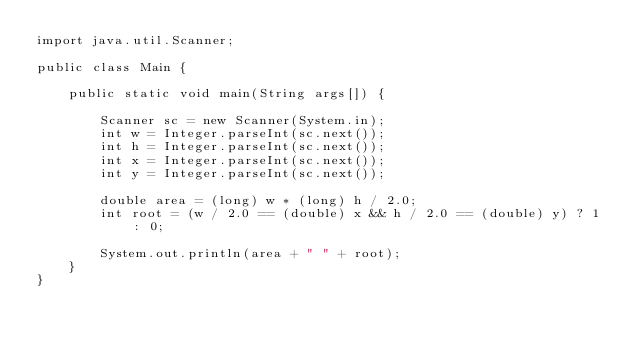Convert code to text. <code><loc_0><loc_0><loc_500><loc_500><_Java_>import java.util.Scanner;

public class Main {

    public static void main(String args[]) {

        Scanner sc = new Scanner(System.in);
        int w = Integer.parseInt(sc.next());
        int h = Integer.parseInt(sc.next());
        int x = Integer.parseInt(sc.next());
        int y = Integer.parseInt(sc.next());

        double area = (long) w * (long) h / 2.0;
        int root = (w / 2.0 == (double) x && h / 2.0 == (double) y) ? 1 : 0;

        System.out.println(area + " " + root);
    }
}
</code> 